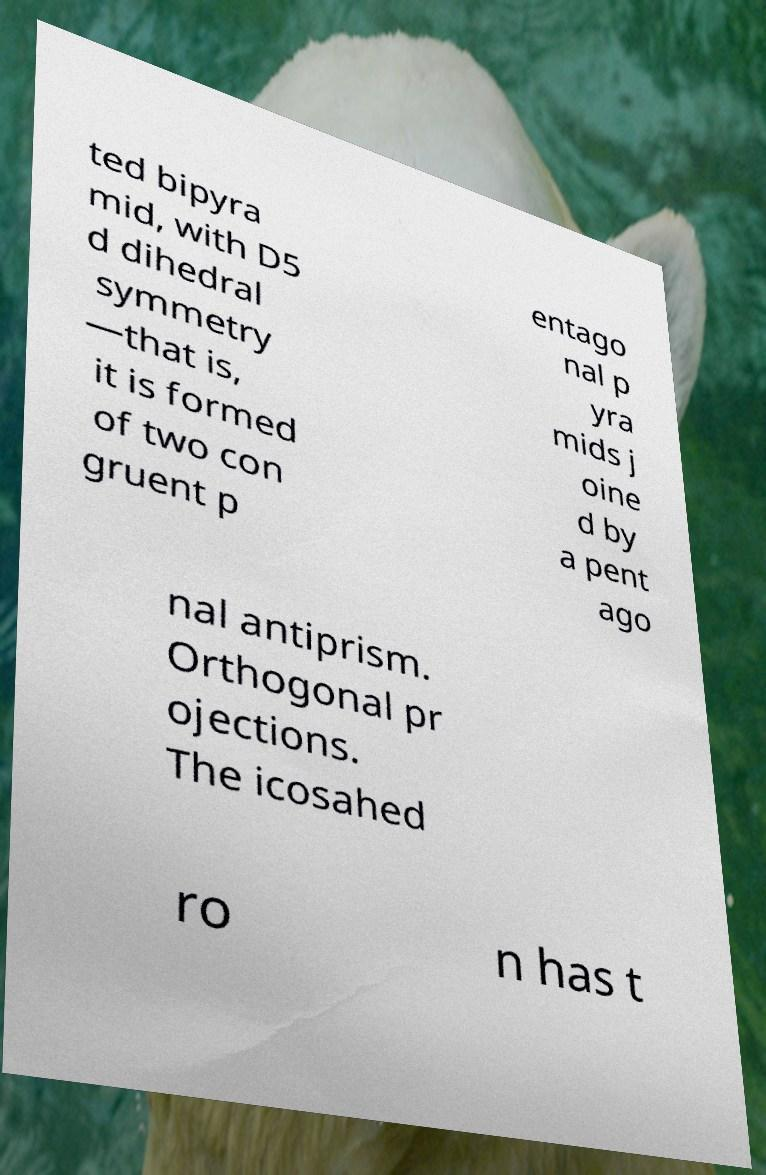Can you read and provide the text displayed in the image?This photo seems to have some interesting text. Can you extract and type it out for me? ted bipyra mid, with D5 d dihedral symmetry —that is, it is formed of two con gruent p entago nal p yra mids j oine d by a pent ago nal antiprism. Orthogonal pr ojections. The icosahed ro n has t 